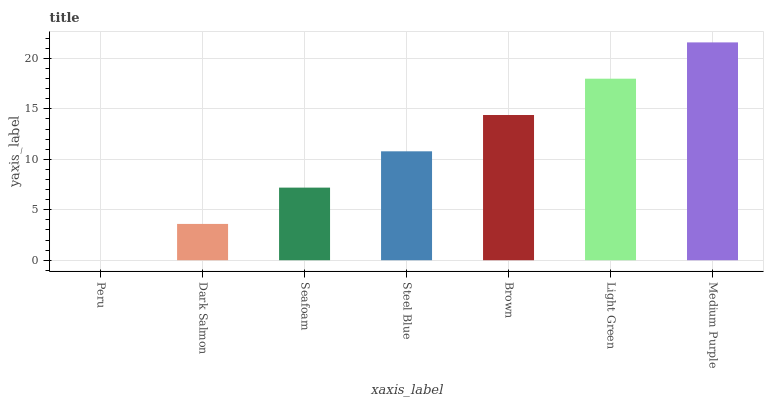Is Dark Salmon the minimum?
Answer yes or no. No. Is Dark Salmon the maximum?
Answer yes or no. No. Is Dark Salmon greater than Peru?
Answer yes or no. Yes. Is Peru less than Dark Salmon?
Answer yes or no. Yes. Is Peru greater than Dark Salmon?
Answer yes or no. No. Is Dark Salmon less than Peru?
Answer yes or no. No. Is Steel Blue the high median?
Answer yes or no. Yes. Is Steel Blue the low median?
Answer yes or no. Yes. Is Medium Purple the high median?
Answer yes or no. No. Is Medium Purple the low median?
Answer yes or no. No. 